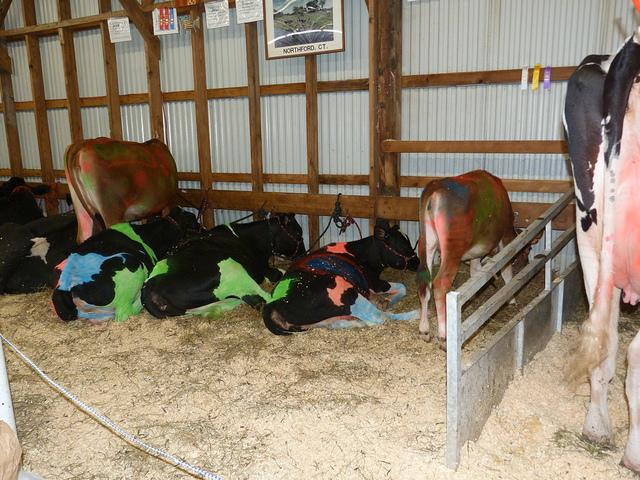What color is the black cow laying down to the right of the green cows? orange 